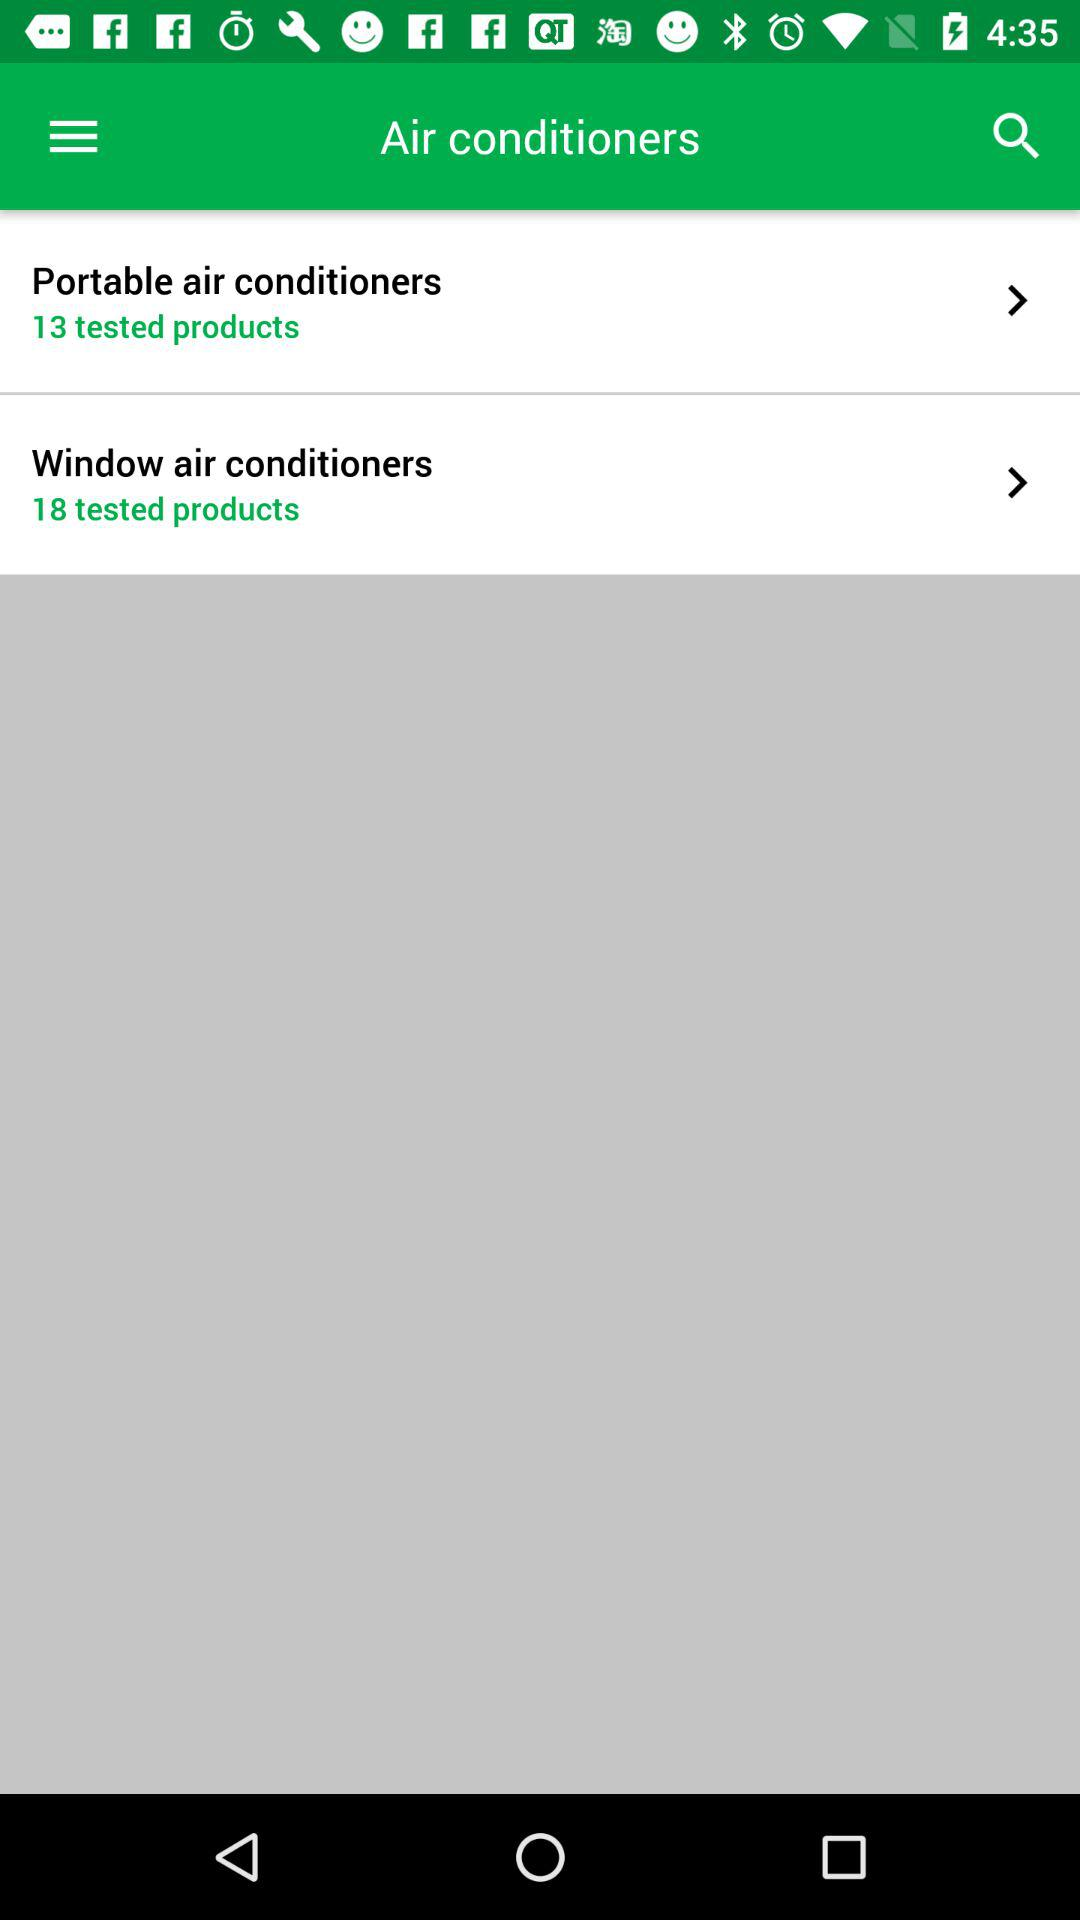What is the number of the products tested for "Window air conditioners"? The number of products tested is 18. 